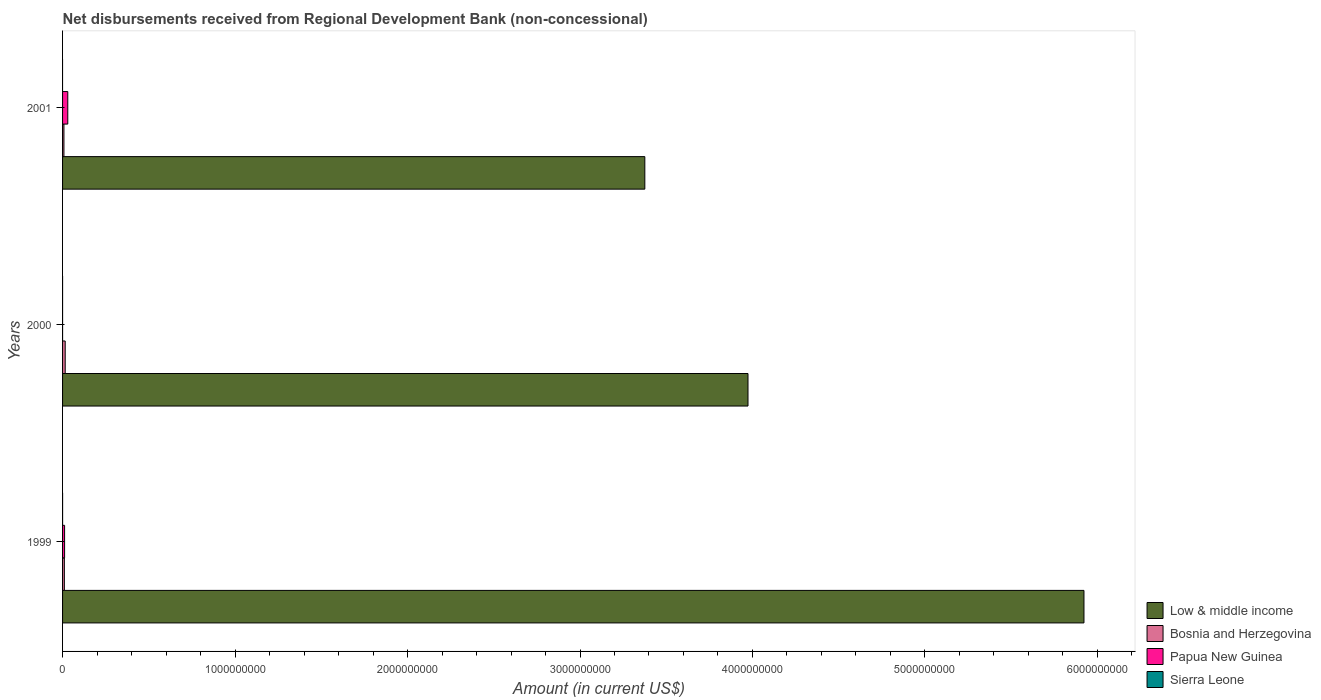How many different coloured bars are there?
Give a very brief answer. 4. Are the number of bars per tick equal to the number of legend labels?
Offer a terse response. No. Are the number of bars on each tick of the Y-axis equal?
Keep it short and to the point. No. How many bars are there on the 3rd tick from the top?
Provide a short and direct response. 4. What is the amount of disbursements received from Regional Development Bank in Papua New Guinea in 2001?
Your answer should be compact. 3.03e+07. Across all years, what is the maximum amount of disbursements received from Regional Development Bank in Bosnia and Herzegovina?
Keep it short and to the point. 1.53e+07. Across all years, what is the minimum amount of disbursements received from Regional Development Bank in Papua New Guinea?
Provide a short and direct response. 8000. In which year was the amount of disbursements received from Regional Development Bank in Low & middle income maximum?
Make the answer very short. 1999. What is the total amount of disbursements received from Regional Development Bank in Papua New Guinea in the graph?
Provide a succinct answer. 4.21e+07. What is the difference between the amount of disbursements received from Regional Development Bank in Bosnia and Herzegovina in 1999 and that in 2000?
Offer a very short reply. -4.87e+06. What is the difference between the amount of disbursements received from Regional Development Bank in Sierra Leone in 2001 and the amount of disbursements received from Regional Development Bank in Bosnia and Herzegovina in 1999?
Your answer should be very brief. -1.04e+07. What is the average amount of disbursements received from Regional Development Bank in Low & middle income per year?
Give a very brief answer. 4.42e+09. In the year 2000, what is the difference between the amount of disbursements received from Regional Development Bank in Sierra Leone and amount of disbursements received from Regional Development Bank in Low & middle income?
Offer a terse response. -3.97e+09. In how many years, is the amount of disbursements received from Regional Development Bank in Bosnia and Herzegovina greater than 4000000000 US$?
Ensure brevity in your answer.  0. What is the ratio of the amount of disbursements received from Regional Development Bank in Low & middle income in 1999 to that in 2001?
Your answer should be compact. 1.75. Is the amount of disbursements received from Regional Development Bank in Papua New Guinea in 1999 less than that in 2000?
Provide a short and direct response. No. What is the difference between the highest and the second highest amount of disbursements received from Regional Development Bank in Bosnia and Herzegovina?
Provide a short and direct response. 4.87e+06. What is the difference between the highest and the lowest amount of disbursements received from Regional Development Bank in Bosnia and Herzegovina?
Offer a very short reply. 7.29e+06. Is it the case that in every year, the sum of the amount of disbursements received from Regional Development Bank in Papua New Guinea and amount of disbursements received from Regional Development Bank in Bosnia and Herzegovina is greater than the sum of amount of disbursements received from Regional Development Bank in Low & middle income and amount of disbursements received from Regional Development Bank in Sierra Leone?
Ensure brevity in your answer.  No. What is the difference between two consecutive major ticks on the X-axis?
Make the answer very short. 1.00e+09. Does the graph contain any zero values?
Your answer should be very brief. Yes. Where does the legend appear in the graph?
Offer a very short reply. Bottom right. How many legend labels are there?
Provide a short and direct response. 4. How are the legend labels stacked?
Make the answer very short. Vertical. What is the title of the graph?
Your answer should be compact. Net disbursements received from Regional Development Bank (non-concessional). Does "Barbados" appear as one of the legend labels in the graph?
Provide a short and direct response. No. What is the Amount (in current US$) in Low & middle income in 1999?
Make the answer very short. 5.92e+09. What is the Amount (in current US$) in Bosnia and Herzegovina in 1999?
Ensure brevity in your answer.  1.04e+07. What is the Amount (in current US$) in Papua New Guinea in 1999?
Your response must be concise. 1.18e+07. What is the Amount (in current US$) of Sierra Leone in 1999?
Give a very brief answer. 3.10e+04. What is the Amount (in current US$) of Low & middle income in 2000?
Your answer should be very brief. 3.97e+09. What is the Amount (in current US$) in Bosnia and Herzegovina in 2000?
Your answer should be very brief. 1.53e+07. What is the Amount (in current US$) in Papua New Guinea in 2000?
Give a very brief answer. 8000. What is the Amount (in current US$) in Sierra Leone in 2000?
Your answer should be very brief. 2.10e+04. What is the Amount (in current US$) of Low & middle income in 2001?
Provide a short and direct response. 3.38e+09. What is the Amount (in current US$) in Bosnia and Herzegovina in 2001?
Keep it short and to the point. 7.99e+06. What is the Amount (in current US$) in Papua New Guinea in 2001?
Offer a terse response. 3.03e+07. Across all years, what is the maximum Amount (in current US$) in Low & middle income?
Offer a terse response. 5.92e+09. Across all years, what is the maximum Amount (in current US$) of Bosnia and Herzegovina?
Keep it short and to the point. 1.53e+07. Across all years, what is the maximum Amount (in current US$) of Papua New Guinea?
Your response must be concise. 3.03e+07. Across all years, what is the maximum Amount (in current US$) of Sierra Leone?
Provide a succinct answer. 3.10e+04. Across all years, what is the minimum Amount (in current US$) of Low & middle income?
Give a very brief answer. 3.38e+09. Across all years, what is the minimum Amount (in current US$) of Bosnia and Herzegovina?
Offer a very short reply. 7.99e+06. Across all years, what is the minimum Amount (in current US$) of Papua New Guinea?
Your answer should be compact. 8000. What is the total Amount (in current US$) of Low & middle income in the graph?
Your response must be concise. 1.33e+1. What is the total Amount (in current US$) in Bosnia and Herzegovina in the graph?
Provide a succinct answer. 3.37e+07. What is the total Amount (in current US$) of Papua New Guinea in the graph?
Your answer should be compact. 4.21e+07. What is the total Amount (in current US$) in Sierra Leone in the graph?
Your response must be concise. 5.20e+04. What is the difference between the Amount (in current US$) of Low & middle income in 1999 and that in 2000?
Provide a short and direct response. 1.95e+09. What is the difference between the Amount (in current US$) of Bosnia and Herzegovina in 1999 and that in 2000?
Give a very brief answer. -4.87e+06. What is the difference between the Amount (in current US$) in Papua New Guinea in 1999 and that in 2000?
Provide a short and direct response. 1.18e+07. What is the difference between the Amount (in current US$) of Sierra Leone in 1999 and that in 2000?
Provide a succinct answer. 10000. What is the difference between the Amount (in current US$) in Low & middle income in 1999 and that in 2001?
Keep it short and to the point. 2.55e+09. What is the difference between the Amount (in current US$) of Bosnia and Herzegovina in 1999 and that in 2001?
Ensure brevity in your answer.  2.42e+06. What is the difference between the Amount (in current US$) in Papua New Guinea in 1999 and that in 2001?
Offer a terse response. -1.85e+07. What is the difference between the Amount (in current US$) of Low & middle income in 2000 and that in 2001?
Your answer should be very brief. 5.98e+08. What is the difference between the Amount (in current US$) in Bosnia and Herzegovina in 2000 and that in 2001?
Ensure brevity in your answer.  7.29e+06. What is the difference between the Amount (in current US$) of Papua New Guinea in 2000 and that in 2001?
Offer a terse response. -3.03e+07. What is the difference between the Amount (in current US$) of Low & middle income in 1999 and the Amount (in current US$) of Bosnia and Herzegovina in 2000?
Keep it short and to the point. 5.91e+09. What is the difference between the Amount (in current US$) of Low & middle income in 1999 and the Amount (in current US$) of Papua New Guinea in 2000?
Your response must be concise. 5.92e+09. What is the difference between the Amount (in current US$) in Low & middle income in 1999 and the Amount (in current US$) in Sierra Leone in 2000?
Provide a short and direct response. 5.92e+09. What is the difference between the Amount (in current US$) of Bosnia and Herzegovina in 1999 and the Amount (in current US$) of Papua New Guinea in 2000?
Your answer should be compact. 1.04e+07. What is the difference between the Amount (in current US$) of Bosnia and Herzegovina in 1999 and the Amount (in current US$) of Sierra Leone in 2000?
Give a very brief answer. 1.04e+07. What is the difference between the Amount (in current US$) in Papua New Guinea in 1999 and the Amount (in current US$) in Sierra Leone in 2000?
Offer a terse response. 1.18e+07. What is the difference between the Amount (in current US$) in Low & middle income in 1999 and the Amount (in current US$) in Bosnia and Herzegovina in 2001?
Offer a very short reply. 5.91e+09. What is the difference between the Amount (in current US$) of Low & middle income in 1999 and the Amount (in current US$) of Papua New Guinea in 2001?
Your answer should be very brief. 5.89e+09. What is the difference between the Amount (in current US$) in Bosnia and Herzegovina in 1999 and the Amount (in current US$) in Papua New Guinea in 2001?
Make the answer very short. -1.99e+07. What is the difference between the Amount (in current US$) in Low & middle income in 2000 and the Amount (in current US$) in Bosnia and Herzegovina in 2001?
Offer a very short reply. 3.97e+09. What is the difference between the Amount (in current US$) in Low & middle income in 2000 and the Amount (in current US$) in Papua New Guinea in 2001?
Give a very brief answer. 3.94e+09. What is the difference between the Amount (in current US$) of Bosnia and Herzegovina in 2000 and the Amount (in current US$) of Papua New Guinea in 2001?
Provide a short and direct response. -1.50e+07. What is the average Amount (in current US$) in Low & middle income per year?
Your answer should be very brief. 4.42e+09. What is the average Amount (in current US$) in Bosnia and Herzegovina per year?
Make the answer very short. 1.12e+07. What is the average Amount (in current US$) in Papua New Guinea per year?
Your answer should be very brief. 1.40e+07. What is the average Amount (in current US$) in Sierra Leone per year?
Offer a very short reply. 1.73e+04. In the year 1999, what is the difference between the Amount (in current US$) of Low & middle income and Amount (in current US$) of Bosnia and Herzegovina?
Give a very brief answer. 5.91e+09. In the year 1999, what is the difference between the Amount (in current US$) in Low & middle income and Amount (in current US$) in Papua New Guinea?
Offer a terse response. 5.91e+09. In the year 1999, what is the difference between the Amount (in current US$) in Low & middle income and Amount (in current US$) in Sierra Leone?
Your answer should be compact. 5.92e+09. In the year 1999, what is the difference between the Amount (in current US$) of Bosnia and Herzegovina and Amount (in current US$) of Papua New Guinea?
Provide a short and direct response. -1.37e+06. In the year 1999, what is the difference between the Amount (in current US$) of Bosnia and Herzegovina and Amount (in current US$) of Sierra Leone?
Your answer should be compact. 1.04e+07. In the year 1999, what is the difference between the Amount (in current US$) in Papua New Guinea and Amount (in current US$) in Sierra Leone?
Offer a terse response. 1.17e+07. In the year 2000, what is the difference between the Amount (in current US$) of Low & middle income and Amount (in current US$) of Bosnia and Herzegovina?
Give a very brief answer. 3.96e+09. In the year 2000, what is the difference between the Amount (in current US$) in Low & middle income and Amount (in current US$) in Papua New Guinea?
Give a very brief answer. 3.97e+09. In the year 2000, what is the difference between the Amount (in current US$) of Low & middle income and Amount (in current US$) of Sierra Leone?
Ensure brevity in your answer.  3.97e+09. In the year 2000, what is the difference between the Amount (in current US$) in Bosnia and Herzegovina and Amount (in current US$) in Papua New Guinea?
Provide a succinct answer. 1.53e+07. In the year 2000, what is the difference between the Amount (in current US$) in Bosnia and Herzegovina and Amount (in current US$) in Sierra Leone?
Offer a very short reply. 1.53e+07. In the year 2000, what is the difference between the Amount (in current US$) in Papua New Guinea and Amount (in current US$) in Sierra Leone?
Your answer should be compact. -1.30e+04. In the year 2001, what is the difference between the Amount (in current US$) in Low & middle income and Amount (in current US$) in Bosnia and Herzegovina?
Your answer should be very brief. 3.37e+09. In the year 2001, what is the difference between the Amount (in current US$) in Low & middle income and Amount (in current US$) in Papua New Guinea?
Your answer should be compact. 3.35e+09. In the year 2001, what is the difference between the Amount (in current US$) in Bosnia and Herzegovina and Amount (in current US$) in Papua New Guinea?
Make the answer very short. -2.23e+07. What is the ratio of the Amount (in current US$) of Low & middle income in 1999 to that in 2000?
Keep it short and to the point. 1.49. What is the ratio of the Amount (in current US$) of Bosnia and Herzegovina in 1999 to that in 2000?
Your answer should be very brief. 0.68. What is the ratio of the Amount (in current US$) of Papua New Guinea in 1999 to that in 2000?
Your response must be concise. 1472.38. What is the ratio of the Amount (in current US$) of Sierra Leone in 1999 to that in 2000?
Your answer should be very brief. 1.48. What is the ratio of the Amount (in current US$) in Low & middle income in 1999 to that in 2001?
Offer a terse response. 1.75. What is the ratio of the Amount (in current US$) of Bosnia and Herzegovina in 1999 to that in 2001?
Your answer should be very brief. 1.3. What is the ratio of the Amount (in current US$) of Papua New Guinea in 1999 to that in 2001?
Make the answer very short. 0.39. What is the ratio of the Amount (in current US$) of Low & middle income in 2000 to that in 2001?
Offer a terse response. 1.18. What is the ratio of the Amount (in current US$) in Bosnia and Herzegovina in 2000 to that in 2001?
Offer a terse response. 1.91. What is the difference between the highest and the second highest Amount (in current US$) of Low & middle income?
Provide a succinct answer. 1.95e+09. What is the difference between the highest and the second highest Amount (in current US$) of Bosnia and Herzegovina?
Ensure brevity in your answer.  4.87e+06. What is the difference between the highest and the second highest Amount (in current US$) of Papua New Guinea?
Offer a very short reply. 1.85e+07. What is the difference between the highest and the lowest Amount (in current US$) in Low & middle income?
Give a very brief answer. 2.55e+09. What is the difference between the highest and the lowest Amount (in current US$) of Bosnia and Herzegovina?
Offer a terse response. 7.29e+06. What is the difference between the highest and the lowest Amount (in current US$) of Papua New Guinea?
Give a very brief answer. 3.03e+07. What is the difference between the highest and the lowest Amount (in current US$) in Sierra Leone?
Give a very brief answer. 3.10e+04. 